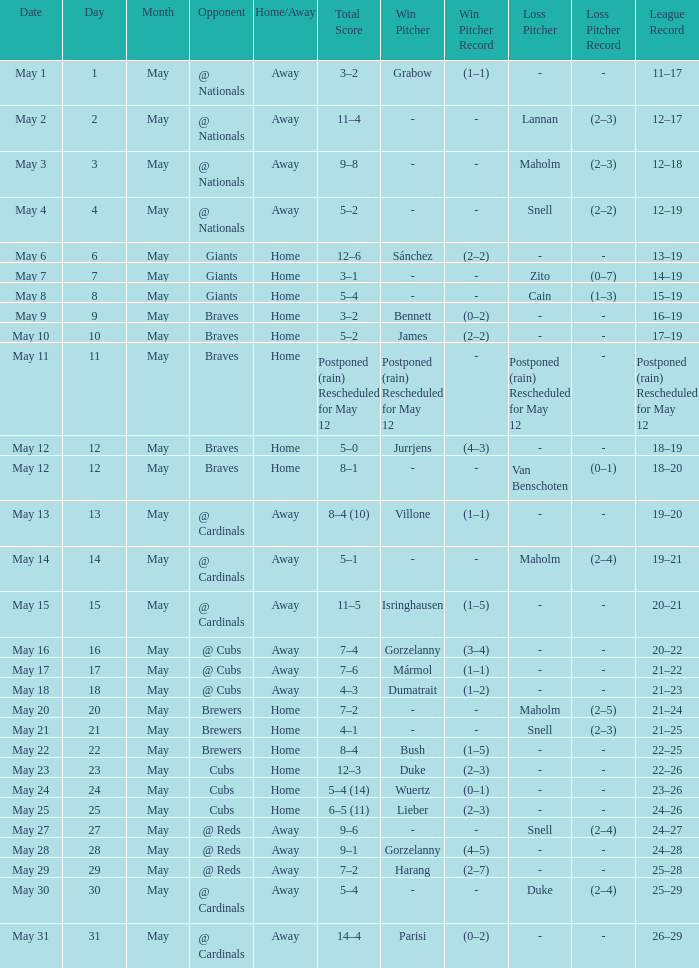What was the date of the game with a loss of Bush (1–5)? May 22. I'm looking to parse the entire table for insights. Could you assist me with that? {'header': ['Date', 'Day', 'Month', 'Opponent', 'Home/Away', 'Total Score', 'Win Pitcher', 'Win Pitcher Record', 'Loss Pitcher', 'Loss Pitcher Record', 'League Record'], 'rows': [['May 1', '1', 'May', '@ Nationals', 'Away', '3–2', 'Grabow', '(1–1)', '-', '-', '11–17'], ['May 2', '2', 'May', '@ Nationals', 'Away', '11–4', '-', '-', 'Lannan', '(2–3)', '12–17'], ['May 3', '3', 'May', '@ Nationals', 'Away', '9–8', '-', '-', 'Maholm', '(2–3)', '12–18'], ['May 4', '4', 'May', '@ Nationals', 'Away', '5–2', '-', '-', 'Snell', '(2–2)', '12–19'], ['May 6', '6', 'May', 'Giants', 'Home', '12–6', 'Sánchez', '(2–2)', '-', '-', '13–19'], ['May 7', '7', 'May', 'Giants', 'Home', '3–1', '-', '-', 'Zito', '(0–7)', '14–19'], ['May 8', '8', 'May', 'Giants', 'Home', '5–4', '-', '-', 'Cain', '(1–3)', '15–19'], ['May 9', '9', 'May', 'Braves', 'Home', '3–2', 'Bennett', '(0–2)', '-', '-', '16–19'], ['May 10', '10', 'May', 'Braves', 'Home', '5–2', 'James', '(2–2)', '-', '-', '17–19'], ['May 11', '11', 'May', 'Braves', 'Home', 'Postponed (rain) Rescheduled for May 12', 'Postponed (rain) Rescheduled for May 12', '-', 'Postponed (rain) Rescheduled for May 12', '-', 'Postponed (rain) Rescheduled for May 12'], ['May 12', '12', 'May', 'Braves', 'Home', '5–0', 'Jurrjens', '(4–3)', '-', '-', '18–19'], ['May 12', '12', 'May', 'Braves', 'Home', '8–1', '-', '-', 'Van Benschoten', '(0–1)', '18–20'], ['May 13', '13', 'May', '@ Cardinals', 'Away', '8–4 (10)', 'Villone', '(1–1)', '-', '-', '19–20'], ['May 14', '14', 'May', '@ Cardinals', 'Away', '5–1', '-', '-', 'Maholm', '(2–4)', '19–21'], ['May 15', '15', 'May', '@ Cardinals', 'Away', '11–5', 'Isringhausen', '(1–5)', '-', '-', '20–21'], ['May 16', '16', 'May', '@ Cubs', 'Away', '7–4', 'Gorzelanny', '(3–4)', '-', '-', '20–22'], ['May 17', '17', 'May', '@ Cubs', 'Away', '7–6', 'Mármol', '(1–1)', '-', '-', '21–22'], ['May 18', '18', 'May', '@ Cubs', 'Away', '4–3', 'Dumatrait', '(1–2)', '-', '-', '21–23'], ['May 20', '20', 'May', 'Brewers', 'Home', '7–2', '-', '-', 'Maholm', '(2–5)', '21–24'], ['May 21', '21', 'May', 'Brewers', 'Home', '4–1', '-', '-', 'Snell', '(2–3)', '21–25'], ['May 22', '22', 'May', 'Brewers', 'Home', '8–4', 'Bush', '(1–5)', '-', '-', '22–25'], ['May 23', '23', 'May', 'Cubs', 'Home', '12–3', 'Duke', '(2–3)', '-', '-', '22–26'], ['May 24', '24', 'May', 'Cubs', 'Home', '5–4 (14)', 'Wuertz', '(0–1)', '-', '-', '23–26'], ['May 25', '25', 'May', 'Cubs', 'Home', '6–5 (11)', 'Lieber', '(2–3)', '-', '-', '24–26'], ['May 27', '27', 'May', '@ Reds', 'Away', '9–6', '-', '-', 'Snell', '(2–4)', '24–27'], ['May 28', '28', 'May', '@ Reds', 'Away', '9–1', 'Gorzelanny', '(4–5)', '-', '-', '24–28'], ['May 29', '29', 'May', '@ Reds', 'Away', '7–2', 'Harang', '(2–7)', '-', '-', '25–28'], ['May 30', '30', 'May', '@ Cardinals', 'Away', '5–4', '-', '-', 'Duke', '(2–4)', '25–29'], ['May 31', '31', 'May', '@ Cardinals', 'Away', '14–4', 'Parisi', '(0–2)', '-', '-', '26–29']]} 